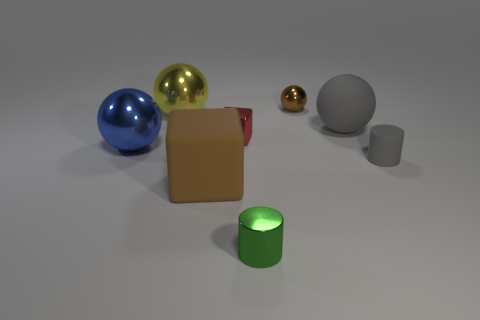Subtract all gray balls. How many balls are left? 3 Add 2 red metallic blocks. How many objects exist? 10 Subtract all brown blocks. How many blocks are left? 1 Subtract all cylinders. How many objects are left? 6 Subtract 0 yellow cylinders. How many objects are left? 8 Subtract 2 balls. How many balls are left? 2 Subtract all brown balls. Subtract all blue cylinders. How many balls are left? 3 Subtract all yellow cylinders. How many brown blocks are left? 1 Subtract all small things. Subtract all large red shiny cubes. How many objects are left? 4 Add 4 tiny metallic things. How many tiny metallic things are left? 7 